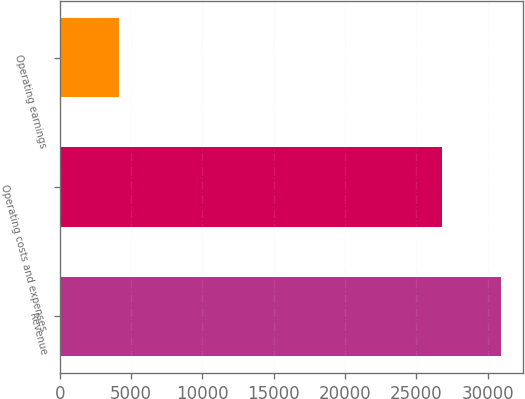<chart> <loc_0><loc_0><loc_500><loc_500><bar_chart><fcel>Revenue<fcel>Operating costs and expenses<fcel>Operating earnings<nl><fcel>30973<fcel>26796<fcel>4177<nl></chart> 